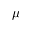<formula> <loc_0><loc_0><loc_500><loc_500>\mu</formula> 